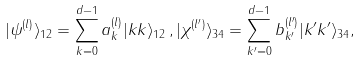<formula> <loc_0><loc_0><loc_500><loc_500>| \psi ^ { ( l ) } \rangle _ { 1 2 } = \sum _ { k = 0 } ^ { d - 1 } a _ { k } ^ { ( l ) } | k k \rangle _ { 1 2 } \, , | \chi ^ { ( l ^ { \prime } ) } \rangle _ { 3 4 } = \sum _ { k ^ { \prime } = 0 } ^ { d - 1 } b _ { k ^ { \prime } } ^ { ( l ^ { \prime } ) } | k ^ { \prime } k ^ { \prime } \rangle _ { 3 4 } ,</formula> 